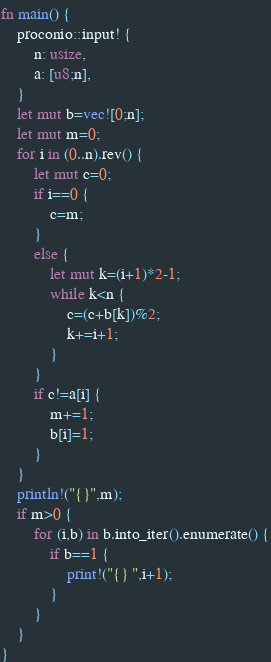<code> <loc_0><loc_0><loc_500><loc_500><_Rust_>fn main() {
    proconio::input! {
        n: usize,
        a: [u8;n],
    }
    let mut b=vec![0;n];
    let mut m=0;
    for i in (0..n).rev() {
        let mut c=0;
        if i==0 {
            c=m;
        }
        else {
            let mut k=(i+1)*2-1;
            while k<n {
                c=(c+b[k])%2;
                k+=i+1;
            }
        }
        if c!=a[i] {
            m+=1;
            b[i]=1;
        }
    }
    println!("{}",m);
    if m>0 {
        for (i,b) in b.into_iter().enumerate() {
            if b==1 {
                print!("{} ",i+1);
            }
        }
    }
}</code> 